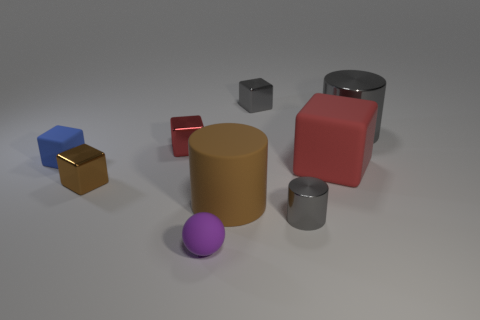Subtract all tiny cylinders. How many cylinders are left? 2 Subtract 4 blocks. How many blocks are left? 1 Subtract all balls. How many objects are left? 8 Subtract all gray cubes. Subtract all yellow cylinders. How many cubes are left? 4 Subtract all red spheres. How many brown cylinders are left? 1 Subtract all big brown matte cylinders. Subtract all tiny gray shiny cubes. How many objects are left? 7 Add 8 large blocks. How many large blocks are left? 9 Add 8 small blue rubber cylinders. How many small blue rubber cylinders exist? 8 Subtract all brown cylinders. How many cylinders are left? 2 Subtract 0 purple cylinders. How many objects are left? 9 